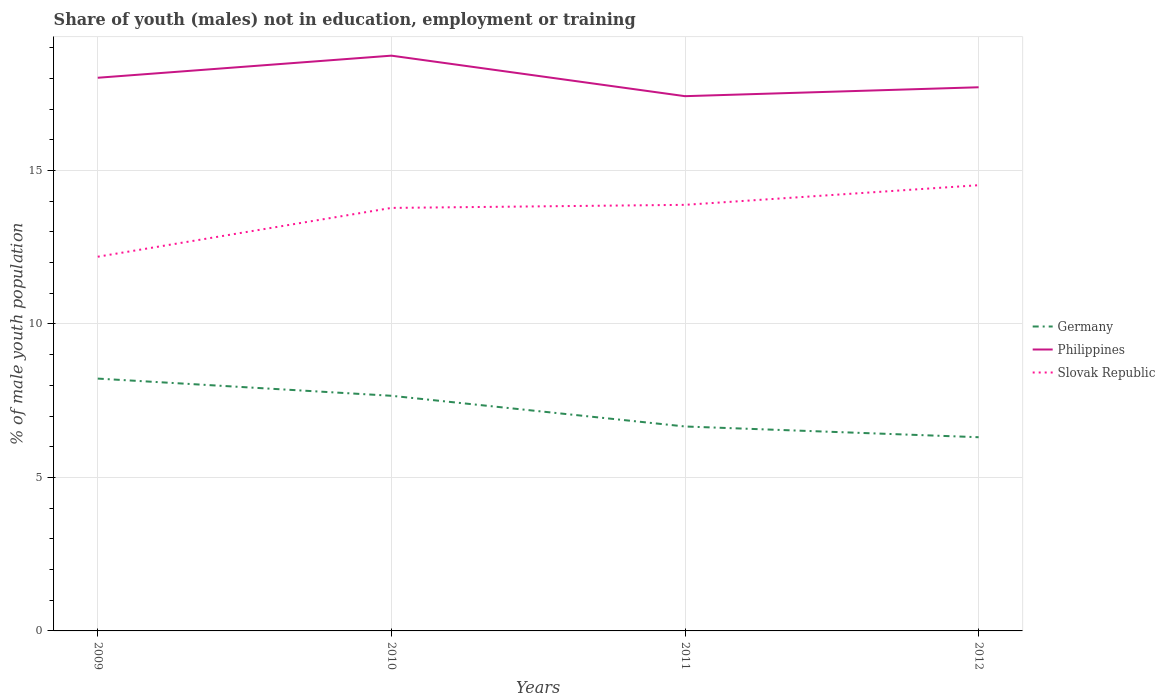How many different coloured lines are there?
Keep it short and to the point. 3. Is the number of lines equal to the number of legend labels?
Your response must be concise. Yes. Across all years, what is the maximum percentage of unemployed males population in in Germany?
Ensure brevity in your answer.  6.31. What is the total percentage of unemployed males population in in Germany in the graph?
Give a very brief answer. 0.56. What is the difference between the highest and the second highest percentage of unemployed males population in in Germany?
Your answer should be compact. 1.91. How many lines are there?
Offer a terse response. 3. How are the legend labels stacked?
Your answer should be compact. Vertical. What is the title of the graph?
Your answer should be compact. Share of youth (males) not in education, employment or training. Does "Myanmar" appear as one of the legend labels in the graph?
Your answer should be compact. No. What is the label or title of the X-axis?
Your answer should be compact. Years. What is the label or title of the Y-axis?
Offer a terse response. % of male youth population. What is the % of male youth population of Germany in 2009?
Provide a succinct answer. 8.22. What is the % of male youth population in Philippines in 2009?
Give a very brief answer. 18.02. What is the % of male youth population in Slovak Republic in 2009?
Your answer should be compact. 12.19. What is the % of male youth population of Germany in 2010?
Provide a short and direct response. 7.66. What is the % of male youth population of Philippines in 2010?
Provide a succinct answer. 18.74. What is the % of male youth population of Slovak Republic in 2010?
Provide a short and direct response. 13.78. What is the % of male youth population in Germany in 2011?
Your answer should be compact. 6.66. What is the % of male youth population of Philippines in 2011?
Your answer should be compact. 17.42. What is the % of male youth population in Slovak Republic in 2011?
Give a very brief answer. 13.88. What is the % of male youth population of Germany in 2012?
Offer a very short reply. 6.31. What is the % of male youth population in Philippines in 2012?
Your response must be concise. 17.71. What is the % of male youth population of Slovak Republic in 2012?
Give a very brief answer. 14.52. Across all years, what is the maximum % of male youth population of Germany?
Provide a short and direct response. 8.22. Across all years, what is the maximum % of male youth population in Philippines?
Offer a terse response. 18.74. Across all years, what is the maximum % of male youth population of Slovak Republic?
Provide a short and direct response. 14.52. Across all years, what is the minimum % of male youth population in Germany?
Give a very brief answer. 6.31. Across all years, what is the minimum % of male youth population in Philippines?
Make the answer very short. 17.42. Across all years, what is the minimum % of male youth population in Slovak Republic?
Keep it short and to the point. 12.19. What is the total % of male youth population in Germany in the graph?
Ensure brevity in your answer.  28.85. What is the total % of male youth population of Philippines in the graph?
Offer a very short reply. 71.89. What is the total % of male youth population in Slovak Republic in the graph?
Give a very brief answer. 54.37. What is the difference between the % of male youth population of Germany in 2009 and that in 2010?
Your response must be concise. 0.56. What is the difference between the % of male youth population of Philippines in 2009 and that in 2010?
Ensure brevity in your answer.  -0.72. What is the difference between the % of male youth population of Slovak Republic in 2009 and that in 2010?
Provide a short and direct response. -1.59. What is the difference between the % of male youth population of Germany in 2009 and that in 2011?
Make the answer very short. 1.56. What is the difference between the % of male youth population of Slovak Republic in 2009 and that in 2011?
Your answer should be compact. -1.69. What is the difference between the % of male youth population in Germany in 2009 and that in 2012?
Provide a succinct answer. 1.91. What is the difference between the % of male youth population of Philippines in 2009 and that in 2012?
Provide a succinct answer. 0.31. What is the difference between the % of male youth population in Slovak Republic in 2009 and that in 2012?
Your answer should be compact. -2.33. What is the difference between the % of male youth population in Philippines in 2010 and that in 2011?
Provide a succinct answer. 1.32. What is the difference between the % of male youth population of Slovak Republic in 2010 and that in 2011?
Your response must be concise. -0.1. What is the difference between the % of male youth population in Germany in 2010 and that in 2012?
Give a very brief answer. 1.35. What is the difference between the % of male youth population in Philippines in 2010 and that in 2012?
Ensure brevity in your answer.  1.03. What is the difference between the % of male youth population in Slovak Republic in 2010 and that in 2012?
Make the answer very short. -0.74. What is the difference between the % of male youth population of Germany in 2011 and that in 2012?
Keep it short and to the point. 0.35. What is the difference between the % of male youth population of Philippines in 2011 and that in 2012?
Give a very brief answer. -0.29. What is the difference between the % of male youth population in Slovak Republic in 2011 and that in 2012?
Keep it short and to the point. -0.64. What is the difference between the % of male youth population of Germany in 2009 and the % of male youth population of Philippines in 2010?
Offer a very short reply. -10.52. What is the difference between the % of male youth population in Germany in 2009 and the % of male youth population in Slovak Republic in 2010?
Your response must be concise. -5.56. What is the difference between the % of male youth population in Philippines in 2009 and the % of male youth population in Slovak Republic in 2010?
Your response must be concise. 4.24. What is the difference between the % of male youth population in Germany in 2009 and the % of male youth population in Slovak Republic in 2011?
Offer a very short reply. -5.66. What is the difference between the % of male youth population in Philippines in 2009 and the % of male youth population in Slovak Republic in 2011?
Ensure brevity in your answer.  4.14. What is the difference between the % of male youth population of Germany in 2009 and the % of male youth population of Philippines in 2012?
Your answer should be very brief. -9.49. What is the difference between the % of male youth population in Philippines in 2009 and the % of male youth population in Slovak Republic in 2012?
Offer a terse response. 3.5. What is the difference between the % of male youth population of Germany in 2010 and the % of male youth population of Philippines in 2011?
Your response must be concise. -9.76. What is the difference between the % of male youth population of Germany in 2010 and the % of male youth population of Slovak Republic in 2011?
Give a very brief answer. -6.22. What is the difference between the % of male youth population in Philippines in 2010 and the % of male youth population in Slovak Republic in 2011?
Your response must be concise. 4.86. What is the difference between the % of male youth population in Germany in 2010 and the % of male youth population in Philippines in 2012?
Make the answer very short. -10.05. What is the difference between the % of male youth population in Germany in 2010 and the % of male youth population in Slovak Republic in 2012?
Offer a terse response. -6.86. What is the difference between the % of male youth population of Philippines in 2010 and the % of male youth population of Slovak Republic in 2012?
Keep it short and to the point. 4.22. What is the difference between the % of male youth population of Germany in 2011 and the % of male youth population of Philippines in 2012?
Ensure brevity in your answer.  -11.05. What is the difference between the % of male youth population of Germany in 2011 and the % of male youth population of Slovak Republic in 2012?
Ensure brevity in your answer.  -7.86. What is the difference between the % of male youth population in Philippines in 2011 and the % of male youth population in Slovak Republic in 2012?
Offer a terse response. 2.9. What is the average % of male youth population in Germany per year?
Offer a very short reply. 7.21. What is the average % of male youth population in Philippines per year?
Your answer should be compact. 17.97. What is the average % of male youth population in Slovak Republic per year?
Offer a terse response. 13.59. In the year 2009, what is the difference between the % of male youth population of Germany and % of male youth population of Slovak Republic?
Provide a succinct answer. -3.97. In the year 2009, what is the difference between the % of male youth population of Philippines and % of male youth population of Slovak Republic?
Make the answer very short. 5.83. In the year 2010, what is the difference between the % of male youth population in Germany and % of male youth population in Philippines?
Provide a short and direct response. -11.08. In the year 2010, what is the difference between the % of male youth population of Germany and % of male youth population of Slovak Republic?
Your answer should be very brief. -6.12. In the year 2010, what is the difference between the % of male youth population in Philippines and % of male youth population in Slovak Republic?
Give a very brief answer. 4.96. In the year 2011, what is the difference between the % of male youth population in Germany and % of male youth population in Philippines?
Your response must be concise. -10.76. In the year 2011, what is the difference between the % of male youth population in Germany and % of male youth population in Slovak Republic?
Give a very brief answer. -7.22. In the year 2011, what is the difference between the % of male youth population in Philippines and % of male youth population in Slovak Republic?
Make the answer very short. 3.54. In the year 2012, what is the difference between the % of male youth population in Germany and % of male youth population in Philippines?
Offer a very short reply. -11.4. In the year 2012, what is the difference between the % of male youth population in Germany and % of male youth population in Slovak Republic?
Keep it short and to the point. -8.21. In the year 2012, what is the difference between the % of male youth population in Philippines and % of male youth population in Slovak Republic?
Keep it short and to the point. 3.19. What is the ratio of the % of male youth population of Germany in 2009 to that in 2010?
Your answer should be very brief. 1.07. What is the ratio of the % of male youth population of Philippines in 2009 to that in 2010?
Provide a short and direct response. 0.96. What is the ratio of the % of male youth population of Slovak Republic in 2009 to that in 2010?
Ensure brevity in your answer.  0.88. What is the ratio of the % of male youth population in Germany in 2009 to that in 2011?
Provide a succinct answer. 1.23. What is the ratio of the % of male youth population of Philippines in 2009 to that in 2011?
Offer a very short reply. 1.03. What is the ratio of the % of male youth population in Slovak Republic in 2009 to that in 2011?
Offer a terse response. 0.88. What is the ratio of the % of male youth population in Germany in 2009 to that in 2012?
Give a very brief answer. 1.3. What is the ratio of the % of male youth population of Philippines in 2009 to that in 2012?
Make the answer very short. 1.02. What is the ratio of the % of male youth population in Slovak Republic in 2009 to that in 2012?
Your response must be concise. 0.84. What is the ratio of the % of male youth population of Germany in 2010 to that in 2011?
Keep it short and to the point. 1.15. What is the ratio of the % of male youth population in Philippines in 2010 to that in 2011?
Provide a short and direct response. 1.08. What is the ratio of the % of male youth population in Slovak Republic in 2010 to that in 2011?
Ensure brevity in your answer.  0.99. What is the ratio of the % of male youth population in Germany in 2010 to that in 2012?
Provide a short and direct response. 1.21. What is the ratio of the % of male youth population of Philippines in 2010 to that in 2012?
Make the answer very short. 1.06. What is the ratio of the % of male youth population in Slovak Republic in 2010 to that in 2012?
Your response must be concise. 0.95. What is the ratio of the % of male youth population in Germany in 2011 to that in 2012?
Provide a short and direct response. 1.06. What is the ratio of the % of male youth population of Philippines in 2011 to that in 2012?
Provide a succinct answer. 0.98. What is the ratio of the % of male youth population of Slovak Republic in 2011 to that in 2012?
Make the answer very short. 0.96. What is the difference between the highest and the second highest % of male youth population of Germany?
Provide a short and direct response. 0.56. What is the difference between the highest and the second highest % of male youth population in Philippines?
Make the answer very short. 0.72. What is the difference between the highest and the second highest % of male youth population in Slovak Republic?
Offer a very short reply. 0.64. What is the difference between the highest and the lowest % of male youth population of Germany?
Ensure brevity in your answer.  1.91. What is the difference between the highest and the lowest % of male youth population of Philippines?
Provide a short and direct response. 1.32. What is the difference between the highest and the lowest % of male youth population in Slovak Republic?
Keep it short and to the point. 2.33. 